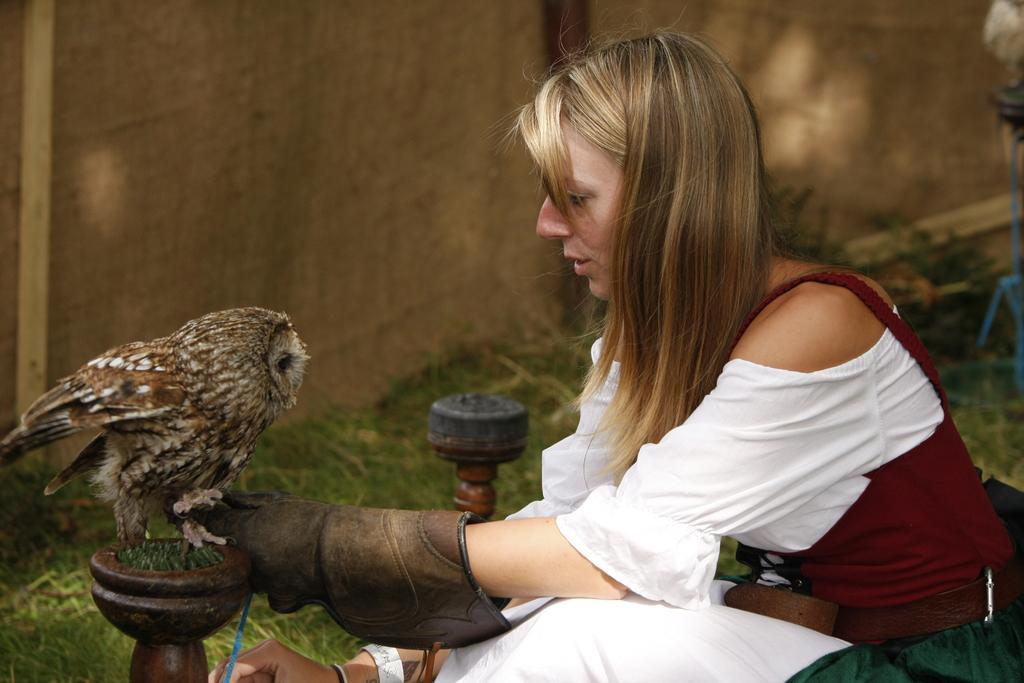What is the lady doing in the image? The lady is sitting in the image. What is in front of the lady? There is an owl in front of the lady. How many objects can be seen in the image? There are two objects in the image. What is the color of the background in the image? The background of the image is dark. What type of roof can be seen on the airplane in the image? There is no airplane present in the image, so there is no roof to be seen. 